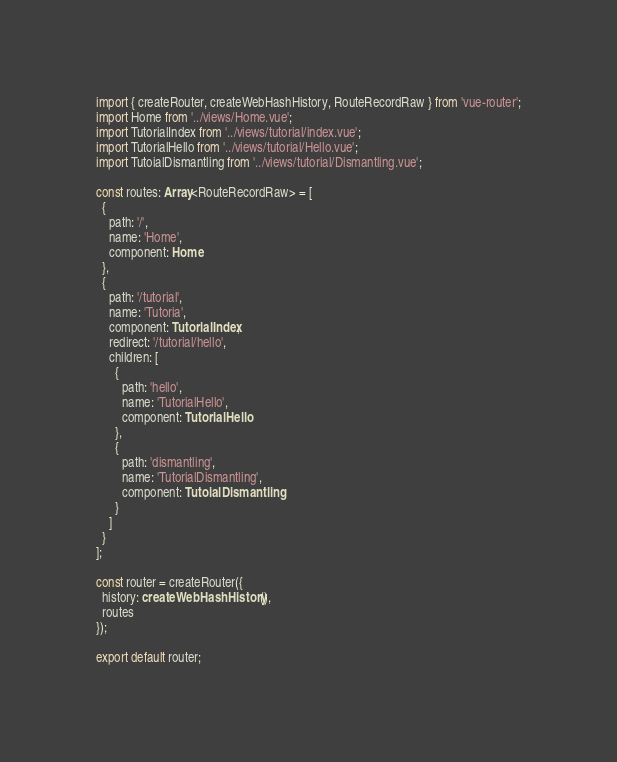Convert code to text. <code><loc_0><loc_0><loc_500><loc_500><_TypeScript_>import { createRouter, createWebHashHistory, RouteRecordRaw } from 'vue-router';
import Home from '../views/Home.vue';
import TutorialIndex from '../views/tutorial/index.vue';
import TutorialHello from '../views/tutorial/Hello.vue';
import TutoialDismantling from '../views/tutorial/Dismantling.vue';

const routes: Array<RouteRecordRaw> = [
  {
    path: '/',
    name: 'Home',
    component: Home
  },
  {
    path: '/tutorial',
    name: 'Tutoria',
    component: TutorialIndex,
    redirect: '/tutorial/hello',
    children: [
      {
        path: 'hello',
        name: 'TutorialHello',
        component: TutorialHello
      },
      {
        path: 'dismantling',
        name: 'TutorialDismantling',
        component: TutoialDismantling
      }
    ]
  }
];

const router = createRouter({
  history: createWebHashHistory(),
  routes
});

export default router;
</code> 